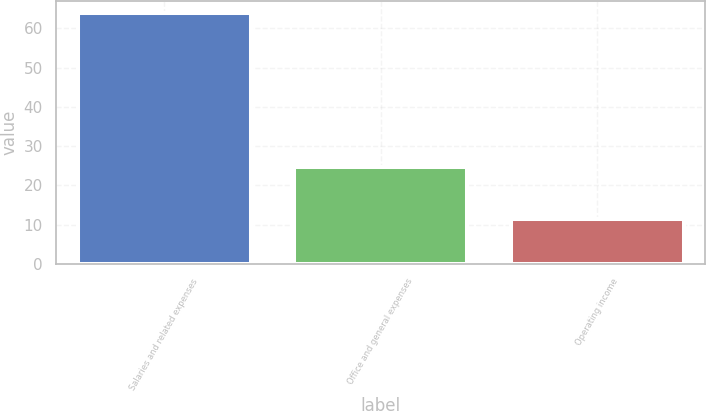<chart> <loc_0><loc_0><loc_500><loc_500><bar_chart><fcel>Salaries and related expenses<fcel>Office and general expenses<fcel>Operating income<nl><fcel>63.8<fcel>24.7<fcel>11.5<nl></chart> 